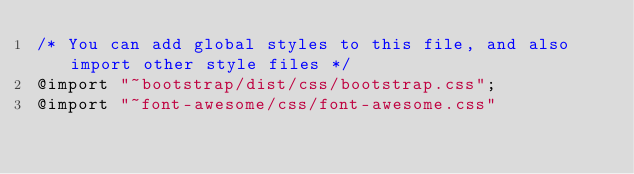<code> <loc_0><loc_0><loc_500><loc_500><_CSS_>/* You can add global styles to this file, and also import other style files */
@import "~bootstrap/dist/css/bootstrap.css";
@import "~font-awesome/css/font-awesome.css"</code> 